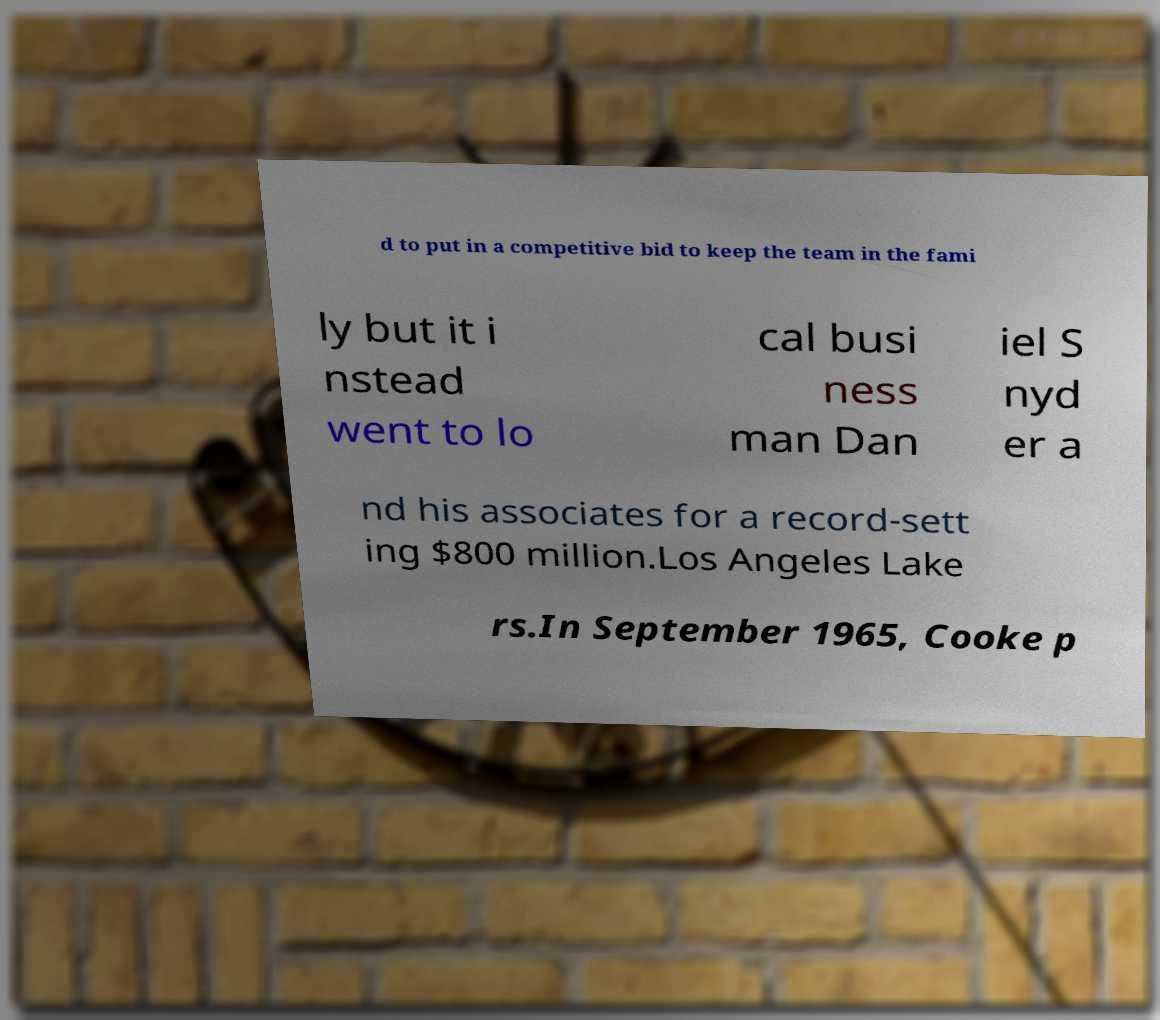There's text embedded in this image that I need extracted. Can you transcribe it verbatim? d to put in a competitive bid to keep the team in the fami ly but it i nstead went to lo cal busi ness man Dan iel S nyd er a nd his associates for a record-sett ing $800 million.Los Angeles Lake rs.In September 1965, Cooke p 